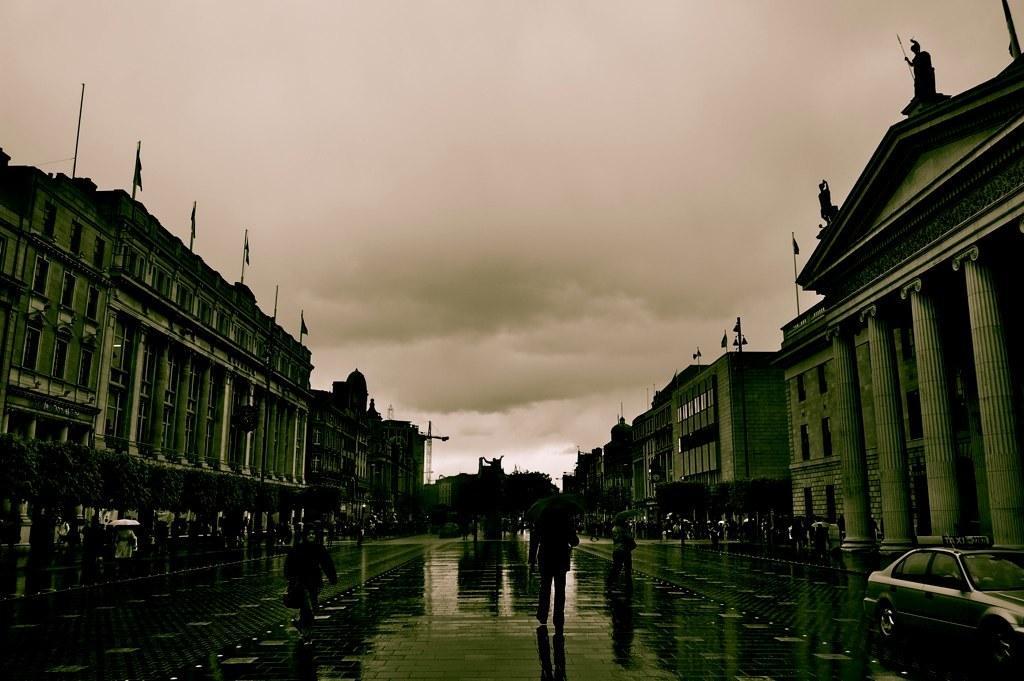Please provide a concise description of this image. This is a black and white image. In this image we can see a group of buildings, some pillars, statues, some poles and the flags. We can also see a group of people and some vehicles on the road. In that some are holding the umbrellas. We can also see a group of plants, trees and the sky which looks cloudy. 